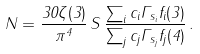<formula> <loc_0><loc_0><loc_500><loc_500>N = \frac { 3 0 \zeta ( 3 ) } { \pi ^ { 4 } } \, S \, \frac { \sum _ { i } c _ { i } \Gamma _ { s _ { i } } f _ { i } ( 3 ) } { \sum _ { j } c _ { j } \Gamma _ { s _ { j } } f _ { j } ( 4 ) } \, .</formula> 